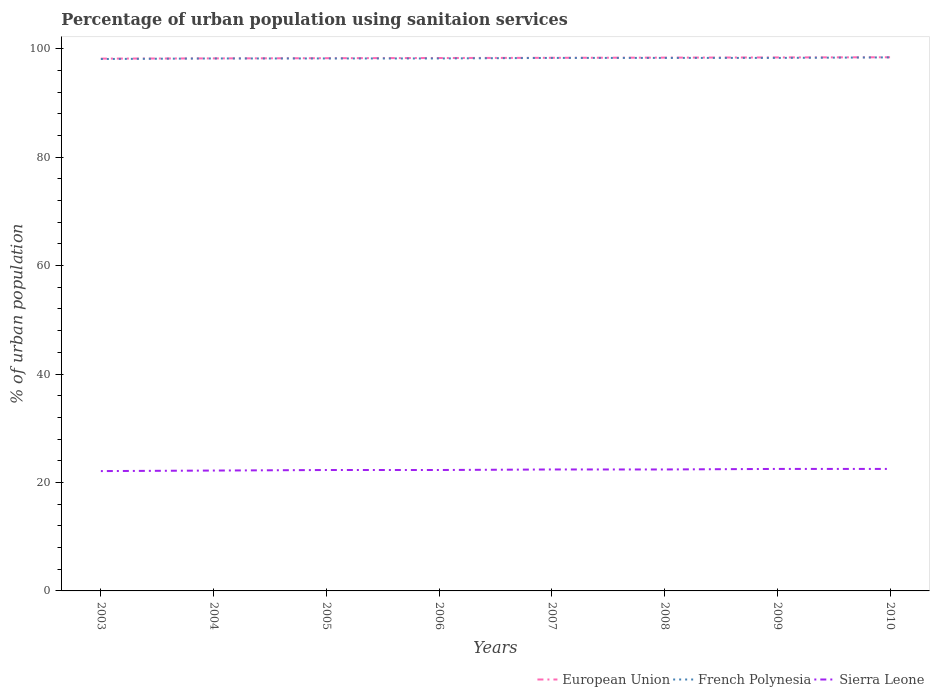Across all years, what is the maximum percentage of urban population using sanitaion services in European Union?
Offer a very short reply. 98.17. What is the total percentage of urban population using sanitaion services in European Union in the graph?
Make the answer very short. -0.04. What is the difference between the highest and the second highest percentage of urban population using sanitaion services in French Polynesia?
Give a very brief answer. 0.3. Is the percentage of urban population using sanitaion services in European Union strictly greater than the percentage of urban population using sanitaion services in French Polynesia over the years?
Offer a very short reply. No. How many years are there in the graph?
Make the answer very short. 8. What is the difference between two consecutive major ticks on the Y-axis?
Provide a short and direct response. 20. Does the graph contain any zero values?
Offer a very short reply. No. Does the graph contain grids?
Make the answer very short. No. Where does the legend appear in the graph?
Provide a short and direct response. Bottom right. How are the legend labels stacked?
Provide a short and direct response. Horizontal. What is the title of the graph?
Offer a very short reply. Percentage of urban population using sanitaion services. What is the label or title of the Y-axis?
Keep it short and to the point. % of urban population. What is the % of urban population in European Union in 2003?
Offer a terse response. 98.17. What is the % of urban population of French Polynesia in 2003?
Ensure brevity in your answer.  98.1. What is the % of urban population in Sierra Leone in 2003?
Offer a terse response. 22.1. What is the % of urban population of European Union in 2004?
Offer a very short reply. 98.21. What is the % of urban population in French Polynesia in 2004?
Keep it short and to the point. 98.2. What is the % of urban population in Sierra Leone in 2004?
Provide a succinct answer. 22.2. What is the % of urban population of European Union in 2005?
Your response must be concise. 98.25. What is the % of urban population in French Polynesia in 2005?
Keep it short and to the point. 98.2. What is the % of urban population of Sierra Leone in 2005?
Your answer should be very brief. 22.3. What is the % of urban population of European Union in 2006?
Offer a terse response. 98.29. What is the % of urban population in French Polynesia in 2006?
Offer a very short reply. 98.2. What is the % of urban population in Sierra Leone in 2006?
Provide a short and direct response. 22.3. What is the % of urban population of European Union in 2007?
Keep it short and to the point. 98.32. What is the % of urban population of French Polynesia in 2007?
Your answer should be compact. 98.3. What is the % of urban population in Sierra Leone in 2007?
Provide a short and direct response. 22.4. What is the % of urban population in European Union in 2008?
Ensure brevity in your answer.  98.36. What is the % of urban population of French Polynesia in 2008?
Give a very brief answer. 98.3. What is the % of urban population of Sierra Leone in 2008?
Your answer should be very brief. 22.4. What is the % of urban population of European Union in 2009?
Your response must be concise. 98.39. What is the % of urban population of French Polynesia in 2009?
Provide a succinct answer. 98.3. What is the % of urban population of European Union in 2010?
Your answer should be compact. 98.42. What is the % of urban population of French Polynesia in 2010?
Give a very brief answer. 98.4. What is the % of urban population in Sierra Leone in 2010?
Keep it short and to the point. 22.5. Across all years, what is the maximum % of urban population of European Union?
Keep it short and to the point. 98.42. Across all years, what is the maximum % of urban population of French Polynesia?
Make the answer very short. 98.4. Across all years, what is the maximum % of urban population of Sierra Leone?
Your response must be concise. 22.5. Across all years, what is the minimum % of urban population of European Union?
Ensure brevity in your answer.  98.17. Across all years, what is the minimum % of urban population in French Polynesia?
Keep it short and to the point. 98.1. Across all years, what is the minimum % of urban population in Sierra Leone?
Offer a very short reply. 22.1. What is the total % of urban population of European Union in the graph?
Give a very brief answer. 786.42. What is the total % of urban population of French Polynesia in the graph?
Offer a very short reply. 786. What is the total % of urban population of Sierra Leone in the graph?
Offer a very short reply. 178.7. What is the difference between the % of urban population in European Union in 2003 and that in 2004?
Ensure brevity in your answer.  -0.04. What is the difference between the % of urban population in French Polynesia in 2003 and that in 2004?
Give a very brief answer. -0.1. What is the difference between the % of urban population of European Union in 2003 and that in 2005?
Your response must be concise. -0.08. What is the difference between the % of urban population in French Polynesia in 2003 and that in 2005?
Your answer should be compact. -0.1. What is the difference between the % of urban population of European Union in 2003 and that in 2006?
Provide a short and direct response. -0.11. What is the difference between the % of urban population of French Polynesia in 2003 and that in 2006?
Make the answer very short. -0.1. What is the difference between the % of urban population in European Union in 2003 and that in 2007?
Offer a very short reply. -0.15. What is the difference between the % of urban population of French Polynesia in 2003 and that in 2007?
Provide a short and direct response. -0.2. What is the difference between the % of urban population in Sierra Leone in 2003 and that in 2007?
Ensure brevity in your answer.  -0.3. What is the difference between the % of urban population in European Union in 2003 and that in 2008?
Ensure brevity in your answer.  -0.18. What is the difference between the % of urban population of Sierra Leone in 2003 and that in 2008?
Your response must be concise. -0.3. What is the difference between the % of urban population of European Union in 2003 and that in 2009?
Keep it short and to the point. -0.22. What is the difference between the % of urban population in Sierra Leone in 2003 and that in 2009?
Provide a succinct answer. -0.4. What is the difference between the % of urban population of European Union in 2003 and that in 2010?
Offer a very short reply. -0.25. What is the difference between the % of urban population in French Polynesia in 2003 and that in 2010?
Provide a short and direct response. -0.3. What is the difference between the % of urban population of Sierra Leone in 2003 and that in 2010?
Make the answer very short. -0.4. What is the difference between the % of urban population in European Union in 2004 and that in 2005?
Ensure brevity in your answer.  -0.04. What is the difference between the % of urban population in Sierra Leone in 2004 and that in 2005?
Your answer should be compact. -0.1. What is the difference between the % of urban population of European Union in 2004 and that in 2006?
Your answer should be compact. -0.07. What is the difference between the % of urban population of Sierra Leone in 2004 and that in 2006?
Offer a very short reply. -0.1. What is the difference between the % of urban population of European Union in 2004 and that in 2007?
Provide a succinct answer. -0.11. What is the difference between the % of urban population in French Polynesia in 2004 and that in 2007?
Give a very brief answer. -0.1. What is the difference between the % of urban population of European Union in 2004 and that in 2008?
Your response must be concise. -0.14. What is the difference between the % of urban population in French Polynesia in 2004 and that in 2008?
Your answer should be compact. -0.1. What is the difference between the % of urban population in European Union in 2004 and that in 2009?
Your response must be concise. -0.18. What is the difference between the % of urban population of European Union in 2004 and that in 2010?
Your answer should be compact. -0.21. What is the difference between the % of urban population in Sierra Leone in 2004 and that in 2010?
Your answer should be compact. -0.3. What is the difference between the % of urban population in European Union in 2005 and that in 2006?
Offer a very short reply. -0.03. What is the difference between the % of urban population of European Union in 2005 and that in 2007?
Your answer should be very brief. -0.07. What is the difference between the % of urban population of French Polynesia in 2005 and that in 2007?
Provide a short and direct response. -0.1. What is the difference between the % of urban population in European Union in 2005 and that in 2008?
Offer a very short reply. -0.11. What is the difference between the % of urban population in French Polynesia in 2005 and that in 2008?
Give a very brief answer. -0.1. What is the difference between the % of urban population of European Union in 2005 and that in 2009?
Offer a very short reply. -0.14. What is the difference between the % of urban population in French Polynesia in 2005 and that in 2009?
Make the answer very short. -0.1. What is the difference between the % of urban population of Sierra Leone in 2005 and that in 2009?
Provide a short and direct response. -0.2. What is the difference between the % of urban population of European Union in 2005 and that in 2010?
Give a very brief answer. -0.17. What is the difference between the % of urban population of French Polynesia in 2005 and that in 2010?
Provide a short and direct response. -0.2. What is the difference between the % of urban population in Sierra Leone in 2005 and that in 2010?
Provide a succinct answer. -0.2. What is the difference between the % of urban population in European Union in 2006 and that in 2007?
Offer a very short reply. -0.04. What is the difference between the % of urban population of Sierra Leone in 2006 and that in 2007?
Provide a succinct answer. -0.1. What is the difference between the % of urban population of European Union in 2006 and that in 2008?
Keep it short and to the point. -0.07. What is the difference between the % of urban population of French Polynesia in 2006 and that in 2008?
Your answer should be very brief. -0.1. What is the difference between the % of urban population of Sierra Leone in 2006 and that in 2008?
Provide a short and direct response. -0.1. What is the difference between the % of urban population of European Union in 2006 and that in 2009?
Offer a terse response. -0.11. What is the difference between the % of urban population in European Union in 2006 and that in 2010?
Make the answer very short. -0.14. What is the difference between the % of urban population in European Union in 2007 and that in 2008?
Your response must be concise. -0.04. What is the difference between the % of urban population in French Polynesia in 2007 and that in 2008?
Provide a short and direct response. 0. What is the difference between the % of urban population of Sierra Leone in 2007 and that in 2008?
Keep it short and to the point. 0. What is the difference between the % of urban population of European Union in 2007 and that in 2009?
Keep it short and to the point. -0.07. What is the difference between the % of urban population in French Polynesia in 2007 and that in 2009?
Make the answer very short. 0. What is the difference between the % of urban population in European Union in 2007 and that in 2010?
Your response must be concise. -0.1. What is the difference between the % of urban population of Sierra Leone in 2007 and that in 2010?
Your answer should be very brief. -0.1. What is the difference between the % of urban population in European Union in 2008 and that in 2009?
Offer a terse response. -0.04. What is the difference between the % of urban population of Sierra Leone in 2008 and that in 2009?
Offer a very short reply. -0.1. What is the difference between the % of urban population in European Union in 2008 and that in 2010?
Provide a short and direct response. -0.06. What is the difference between the % of urban population of Sierra Leone in 2008 and that in 2010?
Provide a short and direct response. -0.1. What is the difference between the % of urban population of European Union in 2009 and that in 2010?
Offer a very short reply. -0.03. What is the difference between the % of urban population of Sierra Leone in 2009 and that in 2010?
Your answer should be compact. 0. What is the difference between the % of urban population of European Union in 2003 and the % of urban population of French Polynesia in 2004?
Offer a very short reply. -0.03. What is the difference between the % of urban population of European Union in 2003 and the % of urban population of Sierra Leone in 2004?
Provide a succinct answer. 75.97. What is the difference between the % of urban population in French Polynesia in 2003 and the % of urban population in Sierra Leone in 2004?
Your response must be concise. 75.9. What is the difference between the % of urban population in European Union in 2003 and the % of urban population in French Polynesia in 2005?
Make the answer very short. -0.03. What is the difference between the % of urban population in European Union in 2003 and the % of urban population in Sierra Leone in 2005?
Your response must be concise. 75.87. What is the difference between the % of urban population of French Polynesia in 2003 and the % of urban population of Sierra Leone in 2005?
Your response must be concise. 75.8. What is the difference between the % of urban population in European Union in 2003 and the % of urban population in French Polynesia in 2006?
Provide a succinct answer. -0.03. What is the difference between the % of urban population in European Union in 2003 and the % of urban population in Sierra Leone in 2006?
Make the answer very short. 75.87. What is the difference between the % of urban population of French Polynesia in 2003 and the % of urban population of Sierra Leone in 2006?
Keep it short and to the point. 75.8. What is the difference between the % of urban population in European Union in 2003 and the % of urban population in French Polynesia in 2007?
Your answer should be compact. -0.13. What is the difference between the % of urban population of European Union in 2003 and the % of urban population of Sierra Leone in 2007?
Ensure brevity in your answer.  75.77. What is the difference between the % of urban population in French Polynesia in 2003 and the % of urban population in Sierra Leone in 2007?
Your response must be concise. 75.7. What is the difference between the % of urban population of European Union in 2003 and the % of urban population of French Polynesia in 2008?
Your response must be concise. -0.13. What is the difference between the % of urban population in European Union in 2003 and the % of urban population in Sierra Leone in 2008?
Ensure brevity in your answer.  75.77. What is the difference between the % of urban population of French Polynesia in 2003 and the % of urban population of Sierra Leone in 2008?
Keep it short and to the point. 75.7. What is the difference between the % of urban population of European Union in 2003 and the % of urban population of French Polynesia in 2009?
Provide a succinct answer. -0.13. What is the difference between the % of urban population in European Union in 2003 and the % of urban population in Sierra Leone in 2009?
Provide a succinct answer. 75.67. What is the difference between the % of urban population of French Polynesia in 2003 and the % of urban population of Sierra Leone in 2009?
Offer a very short reply. 75.6. What is the difference between the % of urban population in European Union in 2003 and the % of urban population in French Polynesia in 2010?
Keep it short and to the point. -0.23. What is the difference between the % of urban population of European Union in 2003 and the % of urban population of Sierra Leone in 2010?
Keep it short and to the point. 75.67. What is the difference between the % of urban population of French Polynesia in 2003 and the % of urban population of Sierra Leone in 2010?
Your answer should be compact. 75.6. What is the difference between the % of urban population of European Union in 2004 and the % of urban population of French Polynesia in 2005?
Provide a short and direct response. 0.01. What is the difference between the % of urban population in European Union in 2004 and the % of urban population in Sierra Leone in 2005?
Make the answer very short. 75.91. What is the difference between the % of urban population of French Polynesia in 2004 and the % of urban population of Sierra Leone in 2005?
Make the answer very short. 75.9. What is the difference between the % of urban population in European Union in 2004 and the % of urban population in French Polynesia in 2006?
Give a very brief answer. 0.01. What is the difference between the % of urban population in European Union in 2004 and the % of urban population in Sierra Leone in 2006?
Offer a terse response. 75.91. What is the difference between the % of urban population of French Polynesia in 2004 and the % of urban population of Sierra Leone in 2006?
Make the answer very short. 75.9. What is the difference between the % of urban population of European Union in 2004 and the % of urban population of French Polynesia in 2007?
Provide a succinct answer. -0.09. What is the difference between the % of urban population in European Union in 2004 and the % of urban population in Sierra Leone in 2007?
Ensure brevity in your answer.  75.81. What is the difference between the % of urban population of French Polynesia in 2004 and the % of urban population of Sierra Leone in 2007?
Ensure brevity in your answer.  75.8. What is the difference between the % of urban population in European Union in 2004 and the % of urban population in French Polynesia in 2008?
Offer a very short reply. -0.09. What is the difference between the % of urban population in European Union in 2004 and the % of urban population in Sierra Leone in 2008?
Give a very brief answer. 75.81. What is the difference between the % of urban population of French Polynesia in 2004 and the % of urban population of Sierra Leone in 2008?
Keep it short and to the point. 75.8. What is the difference between the % of urban population in European Union in 2004 and the % of urban population in French Polynesia in 2009?
Offer a very short reply. -0.09. What is the difference between the % of urban population in European Union in 2004 and the % of urban population in Sierra Leone in 2009?
Keep it short and to the point. 75.71. What is the difference between the % of urban population of French Polynesia in 2004 and the % of urban population of Sierra Leone in 2009?
Offer a very short reply. 75.7. What is the difference between the % of urban population of European Union in 2004 and the % of urban population of French Polynesia in 2010?
Give a very brief answer. -0.19. What is the difference between the % of urban population of European Union in 2004 and the % of urban population of Sierra Leone in 2010?
Make the answer very short. 75.71. What is the difference between the % of urban population of French Polynesia in 2004 and the % of urban population of Sierra Leone in 2010?
Provide a short and direct response. 75.7. What is the difference between the % of urban population of European Union in 2005 and the % of urban population of French Polynesia in 2006?
Give a very brief answer. 0.05. What is the difference between the % of urban population of European Union in 2005 and the % of urban population of Sierra Leone in 2006?
Keep it short and to the point. 75.95. What is the difference between the % of urban population of French Polynesia in 2005 and the % of urban population of Sierra Leone in 2006?
Make the answer very short. 75.9. What is the difference between the % of urban population of European Union in 2005 and the % of urban population of French Polynesia in 2007?
Make the answer very short. -0.05. What is the difference between the % of urban population of European Union in 2005 and the % of urban population of Sierra Leone in 2007?
Keep it short and to the point. 75.85. What is the difference between the % of urban population in French Polynesia in 2005 and the % of urban population in Sierra Leone in 2007?
Your answer should be very brief. 75.8. What is the difference between the % of urban population in European Union in 2005 and the % of urban population in French Polynesia in 2008?
Keep it short and to the point. -0.05. What is the difference between the % of urban population of European Union in 2005 and the % of urban population of Sierra Leone in 2008?
Ensure brevity in your answer.  75.85. What is the difference between the % of urban population of French Polynesia in 2005 and the % of urban population of Sierra Leone in 2008?
Your answer should be very brief. 75.8. What is the difference between the % of urban population in European Union in 2005 and the % of urban population in French Polynesia in 2009?
Your answer should be compact. -0.05. What is the difference between the % of urban population in European Union in 2005 and the % of urban population in Sierra Leone in 2009?
Ensure brevity in your answer.  75.75. What is the difference between the % of urban population in French Polynesia in 2005 and the % of urban population in Sierra Leone in 2009?
Offer a very short reply. 75.7. What is the difference between the % of urban population of European Union in 2005 and the % of urban population of French Polynesia in 2010?
Provide a succinct answer. -0.15. What is the difference between the % of urban population in European Union in 2005 and the % of urban population in Sierra Leone in 2010?
Provide a short and direct response. 75.75. What is the difference between the % of urban population of French Polynesia in 2005 and the % of urban population of Sierra Leone in 2010?
Ensure brevity in your answer.  75.7. What is the difference between the % of urban population of European Union in 2006 and the % of urban population of French Polynesia in 2007?
Make the answer very short. -0.01. What is the difference between the % of urban population of European Union in 2006 and the % of urban population of Sierra Leone in 2007?
Your response must be concise. 75.89. What is the difference between the % of urban population of French Polynesia in 2006 and the % of urban population of Sierra Leone in 2007?
Make the answer very short. 75.8. What is the difference between the % of urban population in European Union in 2006 and the % of urban population in French Polynesia in 2008?
Your response must be concise. -0.01. What is the difference between the % of urban population in European Union in 2006 and the % of urban population in Sierra Leone in 2008?
Offer a terse response. 75.89. What is the difference between the % of urban population of French Polynesia in 2006 and the % of urban population of Sierra Leone in 2008?
Offer a very short reply. 75.8. What is the difference between the % of urban population of European Union in 2006 and the % of urban population of French Polynesia in 2009?
Make the answer very short. -0.01. What is the difference between the % of urban population in European Union in 2006 and the % of urban population in Sierra Leone in 2009?
Offer a very short reply. 75.79. What is the difference between the % of urban population in French Polynesia in 2006 and the % of urban population in Sierra Leone in 2009?
Your response must be concise. 75.7. What is the difference between the % of urban population of European Union in 2006 and the % of urban population of French Polynesia in 2010?
Your answer should be compact. -0.11. What is the difference between the % of urban population in European Union in 2006 and the % of urban population in Sierra Leone in 2010?
Provide a short and direct response. 75.79. What is the difference between the % of urban population in French Polynesia in 2006 and the % of urban population in Sierra Leone in 2010?
Offer a very short reply. 75.7. What is the difference between the % of urban population in European Union in 2007 and the % of urban population in French Polynesia in 2008?
Ensure brevity in your answer.  0.02. What is the difference between the % of urban population of European Union in 2007 and the % of urban population of Sierra Leone in 2008?
Provide a succinct answer. 75.92. What is the difference between the % of urban population in French Polynesia in 2007 and the % of urban population in Sierra Leone in 2008?
Make the answer very short. 75.9. What is the difference between the % of urban population in European Union in 2007 and the % of urban population in French Polynesia in 2009?
Make the answer very short. 0.02. What is the difference between the % of urban population in European Union in 2007 and the % of urban population in Sierra Leone in 2009?
Provide a short and direct response. 75.82. What is the difference between the % of urban population in French Polynesia in 2007 and the % of urban population in Sierra Leone in 2009?
Your answer should be very brief. 75.8. What is the difference between the % of urban population in European Union in 2007 and the % of urban population in French Polynesia in 2010?
Your response must be concise. -0.08. What is the difference between the % of urban population in European Union in 2007 and the % of urban population in Sierra Leone in 2010?
Ensure brevity in your answer.  75.82. What is the difference between the % of urban population of French Polynesia in 2007 and the % of urban population of Sierra Leone in 2010?
Provide a short and direct response. 75.8. What is the difference between the % of urban population of European Union in 2008 and the % of urban population of French Polynesia in 2009?
Provide a succinct answer. 0.06. What is the difference between the % of urban population in European Union in 2008 and the % of urban population in Sierra Leone in 2009?
Your answer should be very brief. 75.86. What is the difference between the % of urban population of French Polynesia in 2008 and the % of urban population of Sierra Leone in 2009?
Make the answer very short. 75.8. What is the difference between the % of urban population in European Union in 2008 and the % of urban population in French Polynesia in 2010?
Ensure brevity in your answer.  -0.04. What is the difference between the % of urban population of European Union in 2008 and the % of urban population of Sierra Leone in 2010?
Make the answer very short. 75.86. What is the difference between the % of urban population of French Polynesia in 2008 and the % of urban population of Sierra Leone in 2010?
Your answer should be compact. 75.8. What is the difference between the % of urban population in European Union in 2009 and the % of urban population in French Polynesia in 2010?
Provide a short and direct response. -0.01. What is the difference between the % of urban population of European Union in 2009 and the % of urban population of Sierra Leone in 2010?
Ensure brevity in your answer.  75.89. What is the difference between the % of urban population of French Polynesia in 2009 and the % of urban population of Sierra Leone in 2010?
Make the answer very short. 75.8. What is the average % of urban population of European Union per year?
Give a very brief answer. 98.3. What is the average % of urban population of French Polynesia per year?
Provide a short and direct response. 98.25. What is the average % of urban population of Sierra Leone per year?
Offer a terse response. 22.34. In the year 2003, what is the difference between the % of urban population in European Union and % of urban population in French Polynesia?
Give a very brief answer. 0.07. In the year 2003, what is the difference between the % of urban population in European Union and % of urban population in Sierra Leone?
Offer a terse response. 76.07. In the year 2003, what is the difference between the % of urban population in French Polynesia and % of urban population in Sierra Leone?
Your answer should be compact. 76. In the year 2004, what is the difference between the % of urban population of European Union and % of urban population of French Polynesia?
Keep it short and to the point. 0.01. In the year 2004, what is the difference between the % of urban population in European Union and % of urban population in Sierra Leone?
Keep it short and to the point. 76.01. In the year 2005, what is the difference between the % of urban population of European Union and % of urban population of French Polynesia?
Offer a very short reply. 0.05. In the year 2005, what is the difference between the % of urban population of European Union and % of urban population of Sierra Leone?
Ensure brevity in your answer.  75.95. In the year 2005, what is the difference between the % of urban population in French Polynesia and % of urban population in Sierra Leone?
Offer a very short reply. 75.9. In the year 2006, what is the difference between the % of urban population in European Union and % of urban population in French Polynesia?
Provide a short and direct response. 0.09. In the year 2006, what is the difference between the % of urban population of European Union and % of urban population of Sierra Leone?
Provide a short and direct response. 75.99. In the year 2006, what is the difference between the % of urban population of French Polynesia and % of urban population of Sierra Leone?
Your answer should be very brief. 75.9. In the year 2007, what is the difference between the % of urban population of European Union and % of urban population of French Polynesia?
Offer a terse response. 0.02. In the year 2007, what is the difference between the % of urban population of European Union and % of urban population of Sierra Leone?
Offer a terse response. 75.92. In the year 2007, what is the difference between the % of urban population of French Polynesia and % of urban population of Sierra Leone?
Offer a terse response. 75.9. In the year 2008, what is the difference between the % of urban population in European Union and % of urban population in French Polynesia?
Your answer should be compact. 0.06. In the year 2008, what is the difference between the % of urban population of European Union and % of urban population of Sierra Leone?
Give a very brief answer. 75.96. In the year 2008, what is the difference between the % of urban population of French Polynesia and % of urban population of Sierra Leone?
Your answer should be compact. 75.9. In the year 2009, what is the difference between the % of urban population of European Union and % of urban population of French Polynesia?
Keep it short and to the point. 0.09. In the year 2009, what is the difference between the % of urban population of European Union and % of urban population of Sierra Leone?
Your answer should be very brief. 75.89. In the year 2009, what is the difference between the % of urban population of French Polynesia and % of urban population of Sierra Leone?
Offer a very short reply. 75.8. In the year 2010, what is the difference between the % of urban population in European Union and % of urban population in French Polynesia?
Your answer should be compact. 0.02. In the year 2010, what is the difference between the % of urban population in European Union and % of urban population in Sierra Leone?
Give a very brief answer. 75.92. In the year 2010, what is the difference between the % of urban population in French Polynesia and % of urban population in Sierra Leone?
Your answer should be very brief. 75.9. What is the ratio of the % of urban population in French Polynesia in 2003 to that in 2004?
Offer a terse response. 1. What is the ratio of the % of urban population in Sierra Leone in 2003 to that in 2004?
Offer a terse response. 1. What is the ratio of the % of urban population of European Union in 2003 to that in 2005?
Your answer should be very brief. 1. What is the ratio of the % of urban population in Sierra Leone in 2003 to that in 2007?
Your answer should be compact. 0.99. What is the ratio of the % of urban population in European Union in 2003 to that in 2008?
Keep it short and to the point. 1. What is the ratio of the % of urban population in Sierra Leone in 2003 to that in 2008?
Provide a short and direct response. 0.99. What is the ratio of the % of urban population in French Polynesia in 2003 to that in 2009?
Offer a very short reply. 1. What is the ratio of the % of urban population of Sierra Leone in 2003 to that in 2009?
Keep it short and to the point. 0.98. What is the ratio of the % of urban population of French Polynesia in 2003 to that in 2010?
Ensure brevity in your answer.  1. What is the ratio of the % of urban population of Sierra Leone in 2003 to that in 2010?
Offer a very short reply. 0.98. What is the ratio of the % of urban population of European Union in 2004 to that in 2005?
Provide a short and direct response. 1. What is the ratio of the % of urban population of French Polynesia in 2004 to that in 2005?
Make the answer very short. 1. What is the ratio of the % of urban population of Sierra Leone in 2004 to that in 2005?
Ensure brevity in your answer.  1. What is the ratio of the % of urban population of French Polynesia in 2004 to that in 2006?
Provide a short and direct response. 1. What is the ratio of the % of urban population of Sierra Leone in 2004 to that in 2006?
Your response must be concise. 1. What is the ratio of the % of urban population in Sierra Leone in 2004 to that in 2007?
Your answer should be very brief. 0.99. What is the ratio of the % of urban population of European Union in 2004 to that in 2008?
Keep it short and to the point. 1. What is the ratio of the % of urban population of French Polynesia in 2004 to that in 2008?
Give a very brief answer. 1. What is the ratio of the % of urban population of Sierra Leone in 2004 to that in 2008?
Make the answer very short. 0.99. What is the ratio of the % of urban population in European Union in 2004 to that in 2009?
Keep it short and to the point. 1. What is the ratio of the % of urban population in Sierra Leone in 2004 to that in 2009?
Offer a terse response. 0.99. What is the ratio of the % of urban population in French Polynesia in 2004 to that in 2010?
Give a very brief answer. 1. What is the ratio of the % of urban population in Sierra Leone in 2004 to that in 2010?
Your answer should be very brief. 0.99. What is the ratio of the % of urban population of French Polynesia in 2005 to that in 2006?
Offer a terse response. 1. What is the ratio of the % of urban population in Sierra Leone in 2005 to that in 2006?
Ensure brevity in your answer.  1. What is the ratio of the % of urban population of European Union in 2005 to that in 2008?
Offer a terse response. 1. What is the ratio of the % of urban population in French Polynesia in 2005 to that in 2008?
Give a very brief answer. 1. What is the ratio of the % of urban population in Sierra Leone in 2005 to that in 2008?
Your answer should be very brief. 1. What is the ratio of the % of urban population in European Union in 2005 to that in 2009?
Your answer should be compact. 1. What is the ratio of the % of urban population of French Polynesia in 2005 to that in 2009?
Your answer should be very brief. 1. What is the ratio of the % of urban population of Sierra Leone in 2005 to that in 2009?
Make the answer very short. 0.99. What is the ratio of the % of urban population in European Union in 2005 to that in 2010?
Your answer should be very brief. 1. What is the ratio of the % of urban population in Sierra Leone in 2005 to that in 2010?
Provide a succinct answer. 0.99. What is the ratio of the % of urban population in European Union in 2006 to that in 2007?
Your answer should be compact. 1. What is the ratio of the % of urban population in French Polynesia in 2006 to that in 2007?
Offer a terse response. 1. What is the ratio of the % of urban population in Sierra Leone in 2006 to that in 2007?
Make the answer very short. 1. What is the ratio of the % of urban population in French Polynesia in 2006 to that in 2008?
Ensure brevity in your answer.  1. What is the ratio of the % of urban population of Sierra Leone in 2006 to that in 2009?
Your answer should be very brief. 0.99. What is the ratio of the % of urban population in European Union in 2007 to that in 2009?
Give a very brief answer. 1. What is the ratio of the % of urban population of French Polynesia in 2007 to that in 2009?
Your response must be concise. 1. What is the ratio of the % of urban population in French Polynesia in 2007 to that in 2010?
Keep it short and to the point. 1. What is the ratio of the % of urban population in Sierra Leone in 2007 to that in 2010?
Provide a short and direct response. 1. What is the ratio of the % of urban population of European Union in 2008 to that in 2009?
Provide a short and direct response. 1. What is the ratio of the % of urban population of Sierra Leone in 2008 to that in 2009?
Provide a short and direct response. 1. What is the ratio of the % of urban population in European Union in 2008 to that in 2010?
Make the answer very short. 1. What is the ratio of the % of urban population in French Polynesia in 2008 to that in 2010?
Make the answer very short. 1. What is the ratio of the % of urban population of Sierra Leone in 2008 to that in 2010?
Provide a succinct answer. 1. What is the difference between the highest and the second highest % of urban population in European Union?
Ensure brevity in your answer.  0.03. What is the difference between the highest and the second highest % of urban population of Sierra Leone?
Give a very brief answer. 0. What is the difference between the highest and the lowest % of urban population of European Union?
Offer a very short reply. 0.25. What is the difference between the highest and the lowest % of urban population in Sierra Leone?
Your answer should be compact. 0.4. 